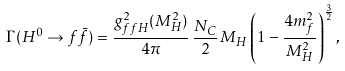Convert formula to latex. <formula><loc_0><loc_0><loc_500><loc_500>\Gamma ( H ^ { 0 } \to f \bar { f } ) = \frac { g ^ { 2 } _ { f f H } ( M _ { H } ^ { 2 } ) } { 4 \pi } \, \frac { N _ { C } } { 2 } \, M _ { H } \left ( 1 - \frac { 4 m _ { f } ^ { 2 } } { M _ { H } ^ { 2 } } \right ) ^ { \frac { 3 } { 2 } } ,</formula> 